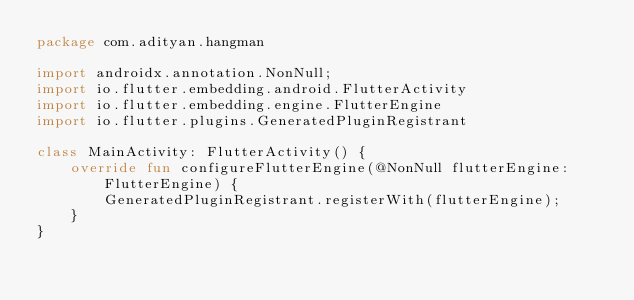<code> <loc_0><loc_0><loc_500><loc_500><_Kotlin_>package com.adityan.hangman

import androidx.annotation.NonNull;
import io.flutter.embedding.android.FlutterActivity
import io.flutter.embedding.engine.FlutterEngine
import io.flutter.plugins.GeneratedPluginRegistrant

class MainActivity: FlutterActivity() {
    override fun configureFlutterEngine(@NonNull flutterEngine: FlutterEngine) {
        GeneratedPluginRegistrant.registerWith(flutterEngine);
    }
}
</code> 